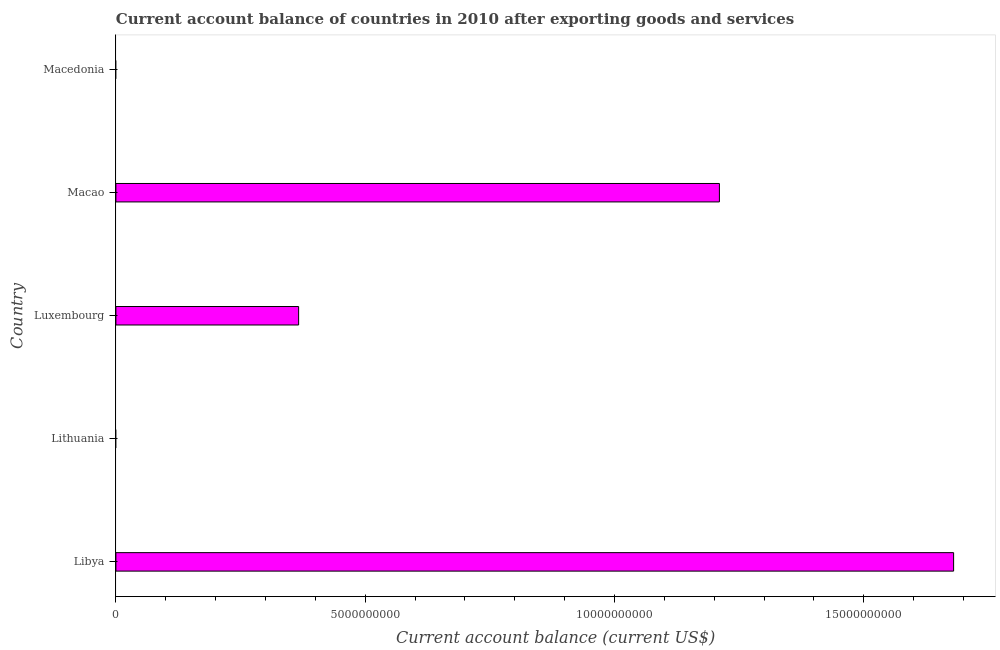Does the graph contain grids?
Your answer should be very brief. No. What is the title of the graph?
Your response must be concise. Current account balance of countries in 2010 after exporting goods and services. What is the label or title of the X-axis?
Your answer should be compact. Current account balance (current US$). Across all countries, what is the maximum current account balance?
Make the answer very short. 1.68e+1. In which country was the current account balance maximum?
Provide a short and direct response. Libya. What is the sum of the current account balance?
Keep it short and to the point. 3.26e+1. What is the difference between the current account balance in Libya and Luxembourg?
Your answer should be compact. 1.31e+1. What is the average current account balance per country?
Offer a very short reply. 6.51e+09. What is the median current account balance?
Offer a very short reply. 3.66e+09. In how many countries, is the current account balance greater than 8000000000 US$?
Give a very brief answer. 2. What is the ratio of the current account balance in Luxembourg to that in Macao?
Your answer should be very brief. 0.3. Is the current account balance in Libya less than that in Macao?
Your answer should be very brief. No. What is the difference between the highest and the second highest current account balance?
Your answer should be very brief. 4.70e+09. What is the difference between the highest and the lowest current account balance?
Provide a short and direct response. 1.68e+1. Are all the bars in the graph horizontal?
Your response must be concise. Yes. How many countries are there in the graph?
Your answer should be very brief. 5. Are the values on the major ticks of X-axis written in scientific E-notation?
Provide a succinct answer. No. What is the Current account balance (current US$) in Libya?
Your response must be concise. 1.68e+1. What is the Current account balance (current US$) in Lithuania?
Provide a short and direct response. 0. What is the Current account balance (current US$) in Luxembourg?
Provide a succinct answer. 3.66e+09. What is the Current account balance (current US$) of Macao?
Give a very brief answer. 1.21e+1. What is the Current account balance (current US$) of Macedonia?
Ensure brevity in your answer.  0. What is the difference between the Current account balance (current US$) in Libya and Luxembourg?
Provide a succinct answer. 1.31e+1. What is the difference between the Current account balance (current US$) in Libya and Macao?
Keep it short and to the point. 4.70e+09. What is the difference between the Current account balance (current US$) in Luxembourg and Macao?
Ensure brevity in your answer.  -8.44e+09. What is the ratio of the Current account balance (current US$) in Libya to that in Luxembourg?
Offer a very short reply. 4.58. What is the ratio of the Current account balance (current US$) in Libya to that in Macao?
Your response must be concise. 1.39. What is the ratio of the Current account balance (current US$) in Luxembourg to that in Macao?
Ensure brevity in your answer.  0.3. 